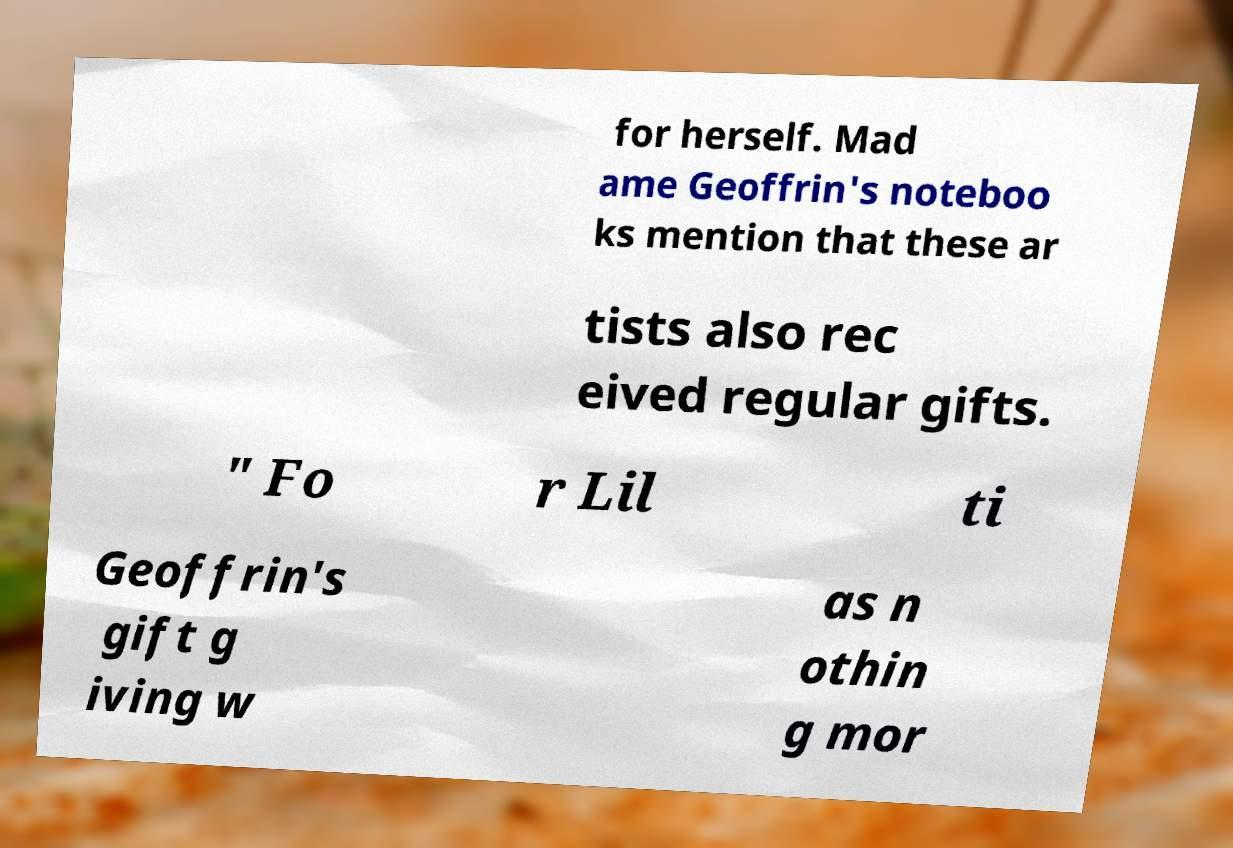Please identify and transcribe the text found in this image. for herself. Mad ame Geoffrin's noteboo ks mention that these ar tists also rec eived regular gifts. " Fo r Lil ti Geoffrin's gift g iving w as n othin g mor 